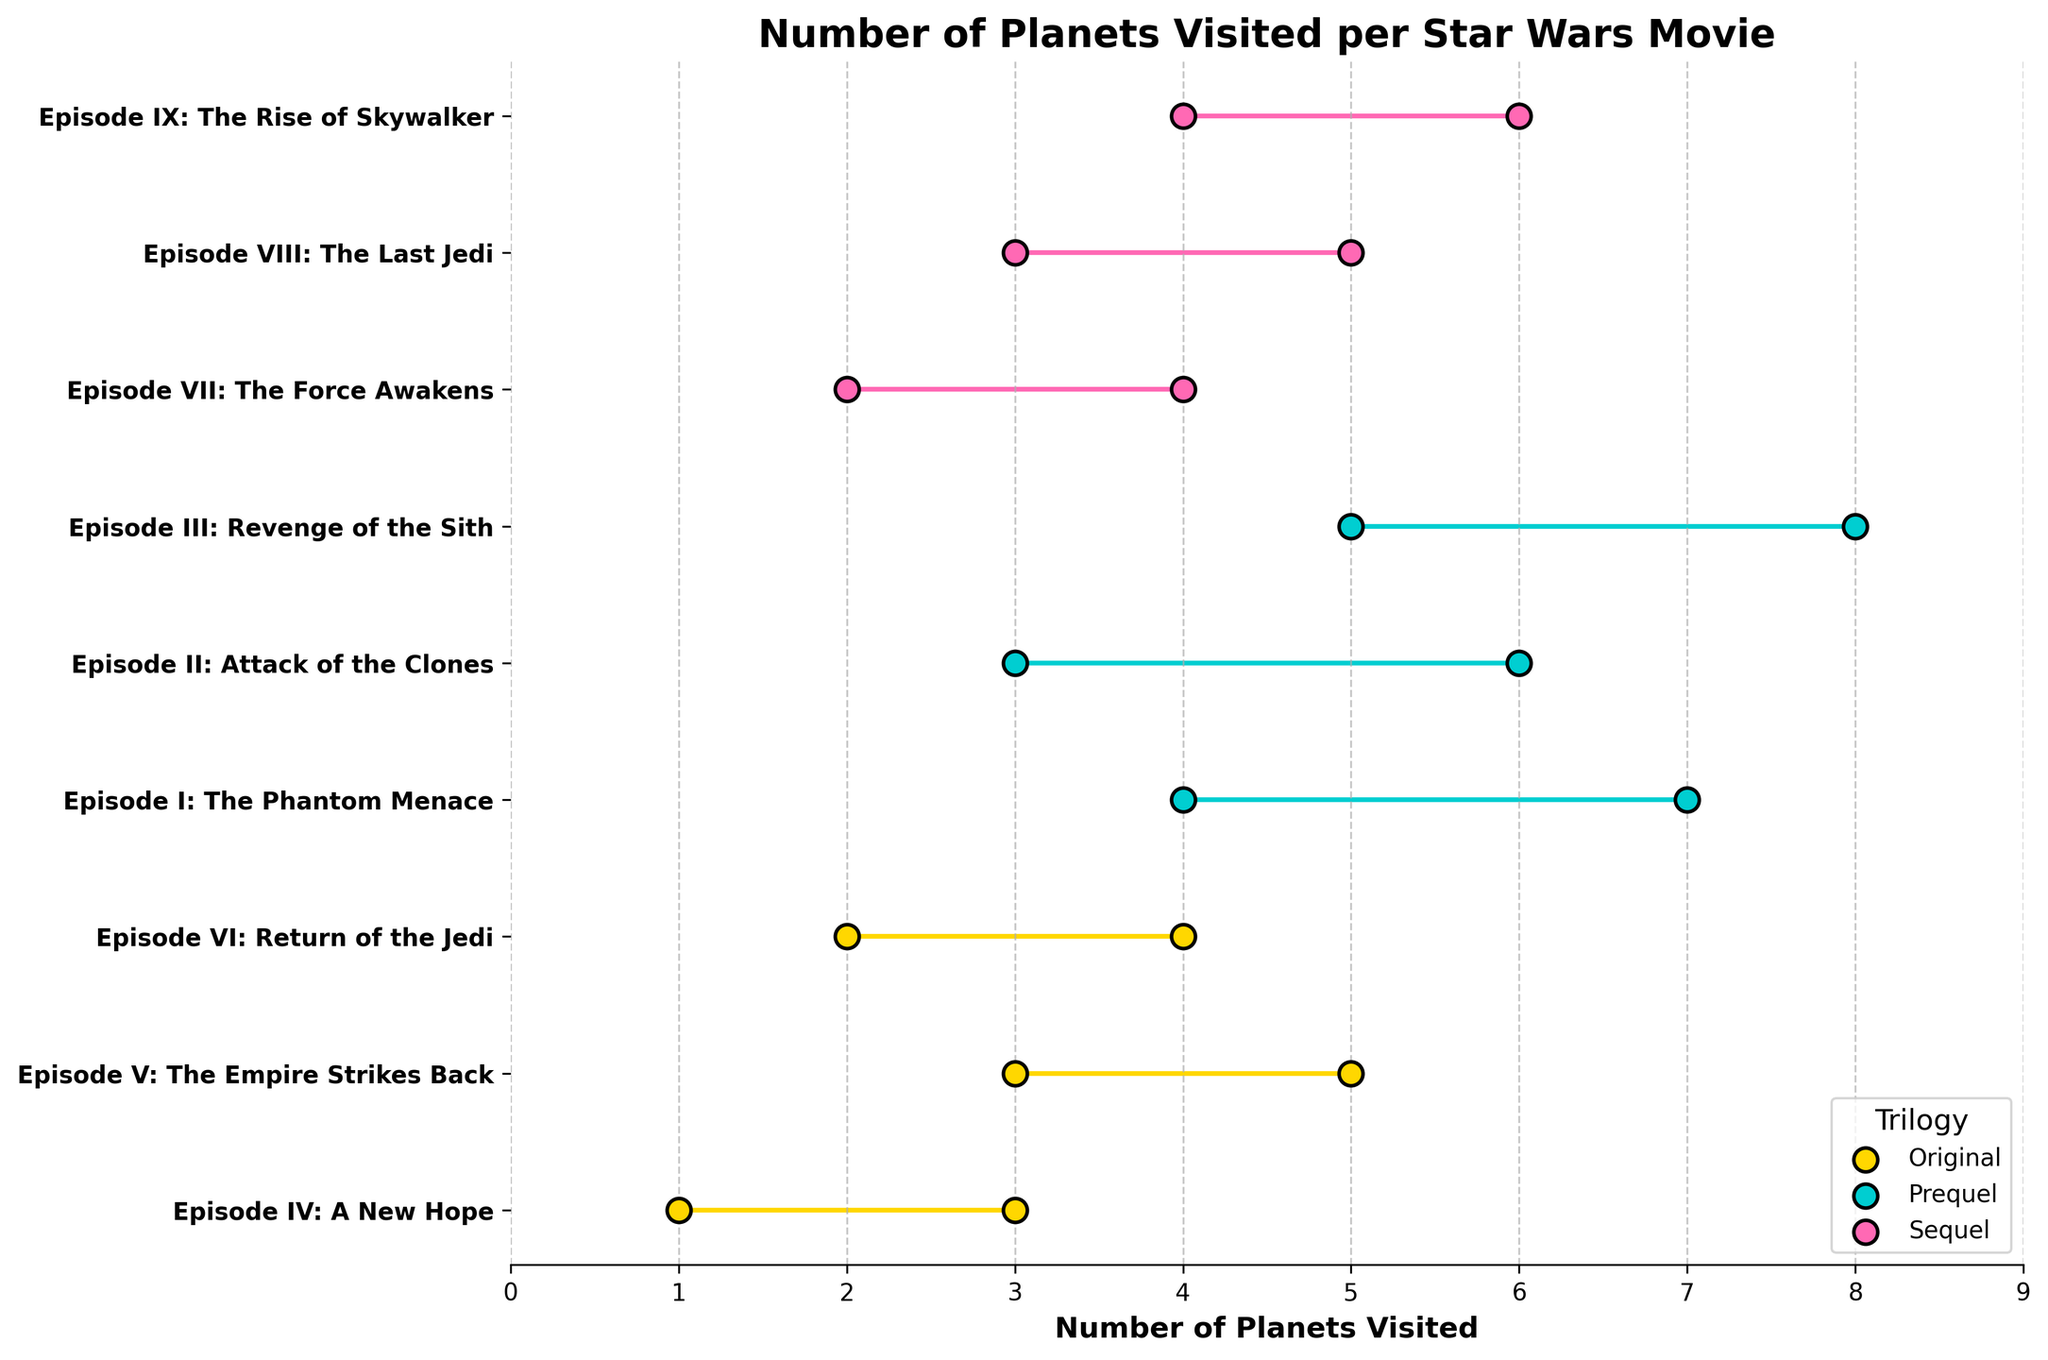what is the minimum and maximum number of planets visited in "Episode III: Revenge of the Sith"? According to the figure, "Episode III: Revenge of the Sith" has a range where the minimum number of planets visited is at 5 and the maximum number is at 8.
Answer: Min: 5, Max: 8 Which trilogy has the highest single maximum number of planets visited? The Prequel Trilogy has the highest single maximum number of planets visited, as indicated by "Episode III: Revenge of the Sith" which visits up to 8 planets. This is higher than the maximum number visited in other trilogies.
Answer: Prequel How many movies have a minimum of 3 planets visited? Looking at the plot, the movies with a minimum number of 3 planets visited are "Episode V: The Empire Strikes Back", "Episode II: Attack of the Clones", and "Episode VIII: The Last Jedi". Therefore, there are 3 movies in total.
Answer: 3 Compare "Episode VII: The Force Awakens" and "Episode IV: A New Hope". Which movie visits more planets at maximum? The figure shows that "Episode VII: The Force Awakens" has a maximum of 4 planets visited, while "Episode IV: A New Hope" has a maximum of 3 planets visited. "Episode VII: The Force Awakens" thus has more planets visited at maximum.
Answer: Episode VII: The Force Awakens What is the average of the minimum number of planets visited in the Original Trilogy? The Original Trilogy includes "Episode IV: A New Hope" (Min: 1), "Episode V: The Empire Strikes Back" (Min: 3), and "Episode VI: Return of the Jedi" (Min: 2). The average is calculated as (1 + 3 + 2) / 3 = 2.
Answer: 2 Is there any movie with the same number of minimum and maximum planets visited? To determine this, check the given ranges on the figure. No movie shows the same number for both minimum and maximum planets visited.
Answer: No Which movie in the Sequel Trilogy visits the minimum number of planets with a count of 2? According to the figure, in the Sequel Trilogy, "Episode VII: The Force Awakens" has a minimum count of 2 planets visited, as indicated by its range.
Answer: Episode VII: The Force Awakens Which movie visits between 4 to 6 planets according to its range? From the figure, "Episode II: Attack of the Clones" (3-6), "Episode III: Revenge of the Sith" (5-8), and "Episode IX: The Rise of Skywalker" (4-6) all show ranges including between 4 to 6 planets.
Answer: Episode II, Episode III, Episode IX 